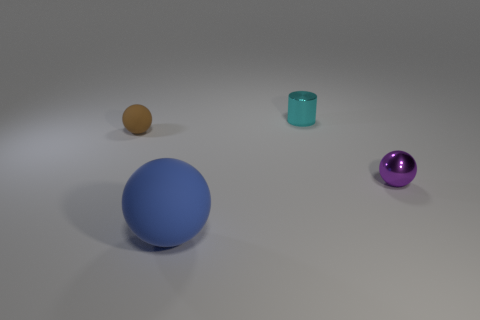Subtract all small brown matte balls. How many balls are left? 2 Subtract all brown spheres. How many spheres are left? 2 Subtract 1 spheres. How many spheres are left? 2 Subtract all purple spheres. Subtract all cyan cylinders. How many spheres are left? 2 Subtract all green cubes. How many blue spheres are left? 1 Add 4 blue rubber things. How many objects exist? 8 Subtract 0 red balls. How many objects are left? 4 Subtract all cylinders. How many objects are left? 3 Subtract all gray shiny spheres. Subtract all blue spheres. How many objects are left? 3 Add 3 tiny cylinders. How many tiny cylinders are left? 4 